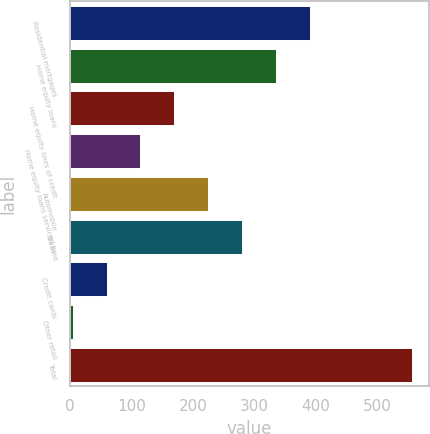Convert chart to OTSL. <chart><loc_0><loc_0><loc_500><loc_500><bar_chart><fcel>Residential mortgages<fcel>Home equity loans<fcel>Home equity lines of credit<fcel>Home equity loans serviced by<fcel>Automobile<fcel>Student<fcel>Credit cards<fcel>Other retail<fcel>Total<nl><fcel>390.4<fcel>335.2<fcel>169.6<fcel>114.4<fcel>224.8<fcel>280<fcel>59.2<fcel>4<fcel>556<nl></chart> 